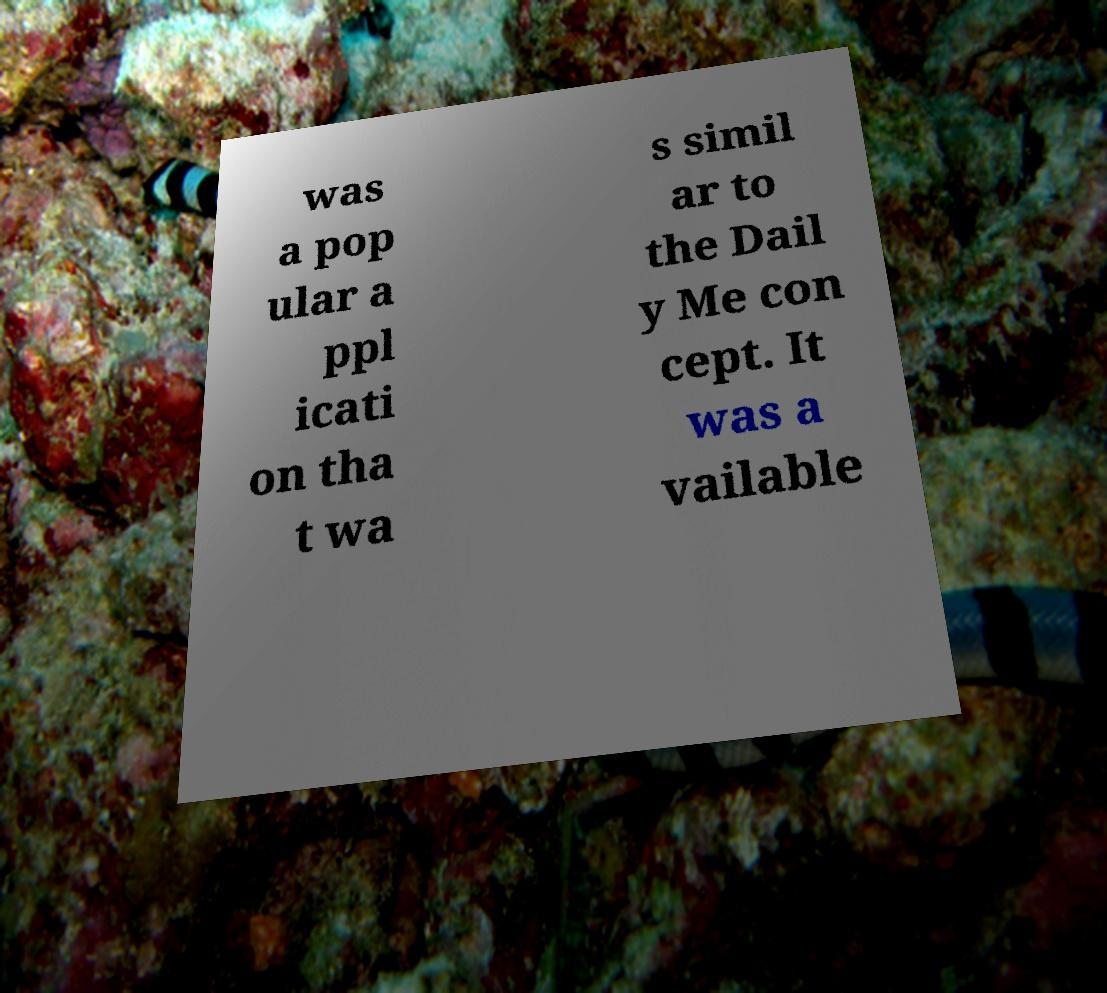Please read and relay the text visible in this image. What does it say? was a pop ular a ppl icati on tha t wa s simil ar to the Dail y Me con cept. It was a vailable 